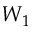<formula> <loc_0><loc_0><loc_500><loc_500>W _ { 1 }</formula> 